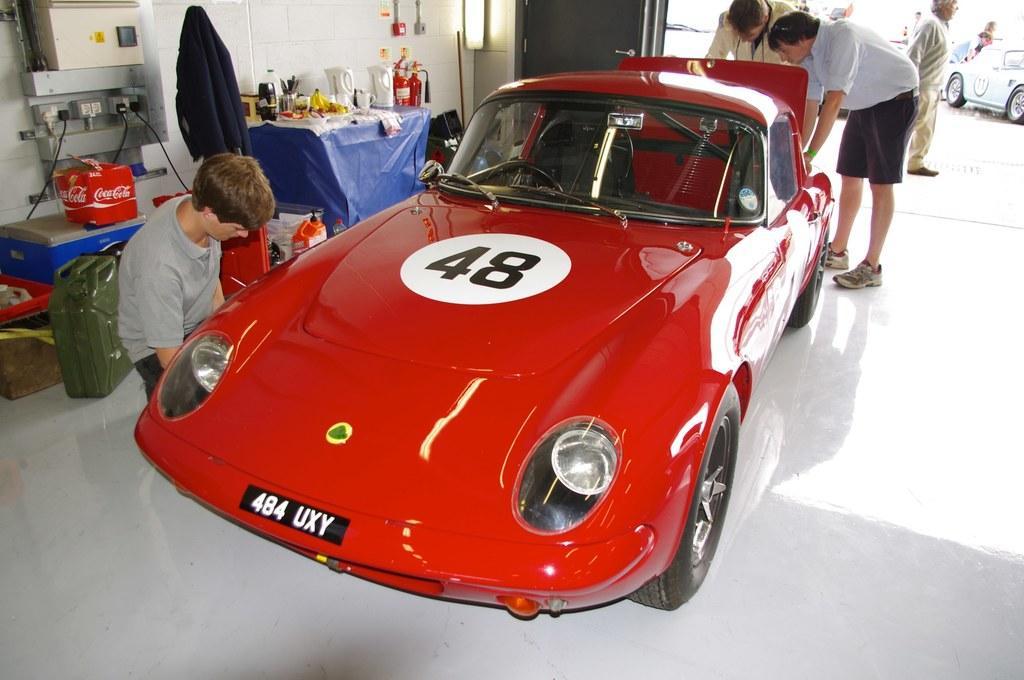Could you give a brief overview of what you see in this image? In this image we can see some cars placed on the surface and some people standing beside them. On the backside we can see a table containing some jars, bottles and some pens in a stand. We can also see fire extinguishers, containers, a door and a machine with some wires. 